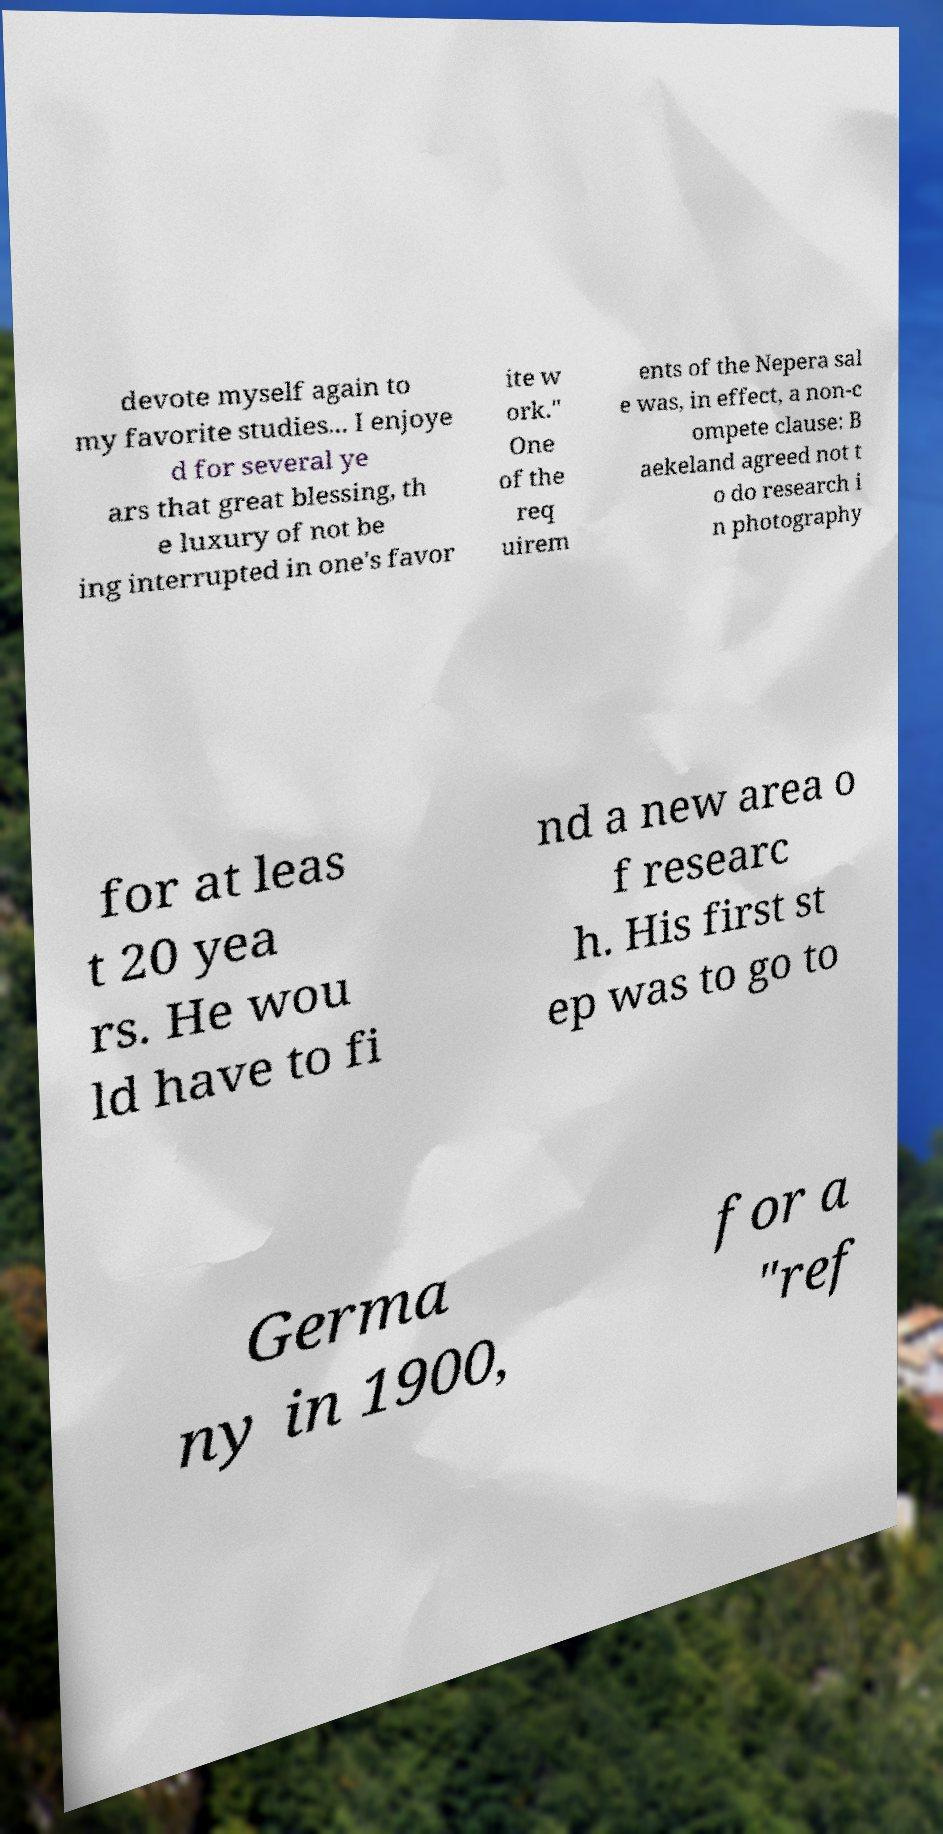I need the written content from this picture converted into text. Can you do that? devote myself again to my favorite studies... I enjoye d for several ye ars that great blessing, th e luxury of not be ing interrupted in one's favor ite w ork." One of the req uirem ents of the Nepera sal e was, in effect, a non-c ompete clause: B aekeland agreed not t o do research i n photography for at leas t 20 yea rs. He wou ld have to fi nd a new area o f researc h. His first st ep was to go to Germa ny in 1900, for a "ref 